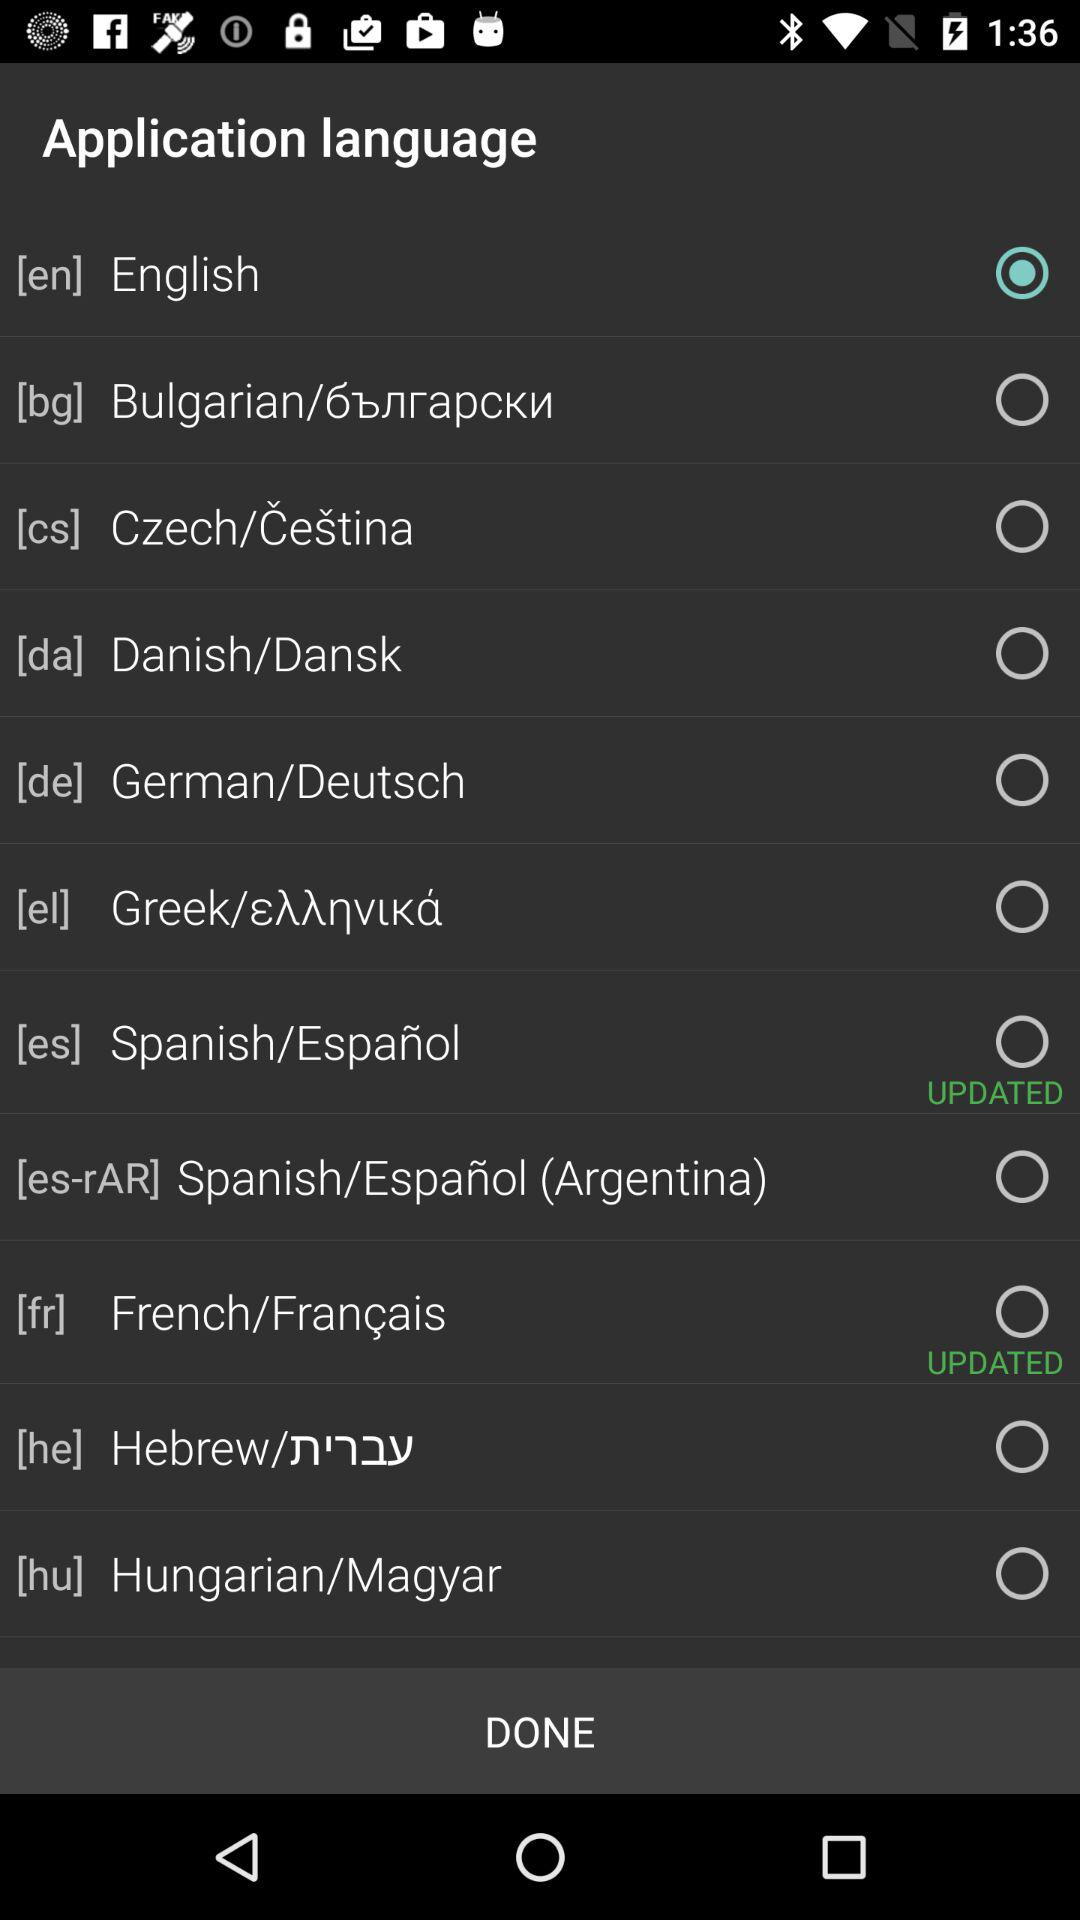Which language is selected? The selected language is English. 